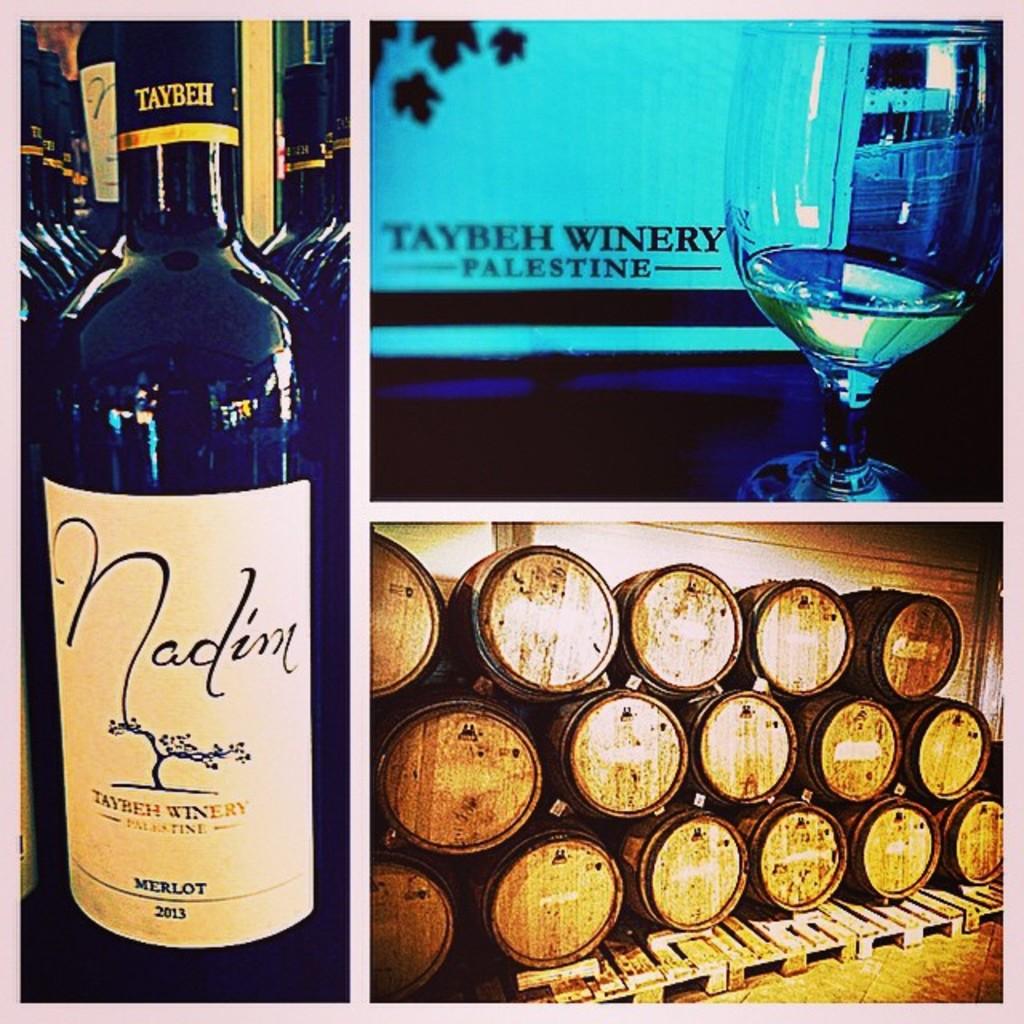What brand of wine?
Your answer should be very brief. Nadin. Where is the taybeh winery located?
Provide a short and direct response. Palestine. 